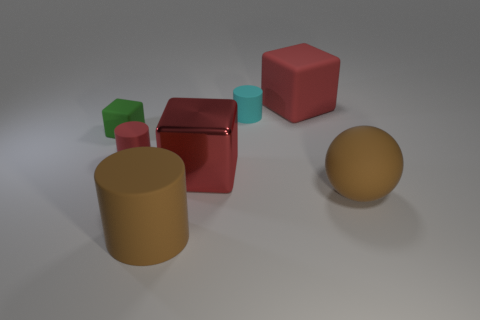Are there any other small rubber objects that have the same shape as the cyan object?
Your answer should be compact. Yes. What shape is the large object that is both right of the big metallic cube and left of the large rubber sphere?
Provide a short and direct response. Cube. What number of large brown things are the same material as the green thing?
Give a very brief answer. 2. Is the number of large matte blocks right of the brown rubber sphere less than the number of blue cylinders?
Your answer should be compact. No. There is a cube that is on the left side of the brown matte cylinder; are there any matte objects behind it?
Provide a short and direct response. Yes. Does the red cylinder have the same size as the brown sphere?
Ensure brevity in your answer.  No. What material is the tiny thing to the right of the cylinder in front of the tiny rubber cylinder in front of the tiny rubber block?
Provide a short and direct response. Rubber. Is the number of tiny cubes in front of the red metal cube the same as the number of large yellow blocks?
Provide a short and direct response. Yes. How many objects are red things or small red cylinders?
Offer a very short reply. 3. The tiny red thing that is made of the same material as the cyan cylinder is what shape?
Provide a succinct answer. Cylinder. 